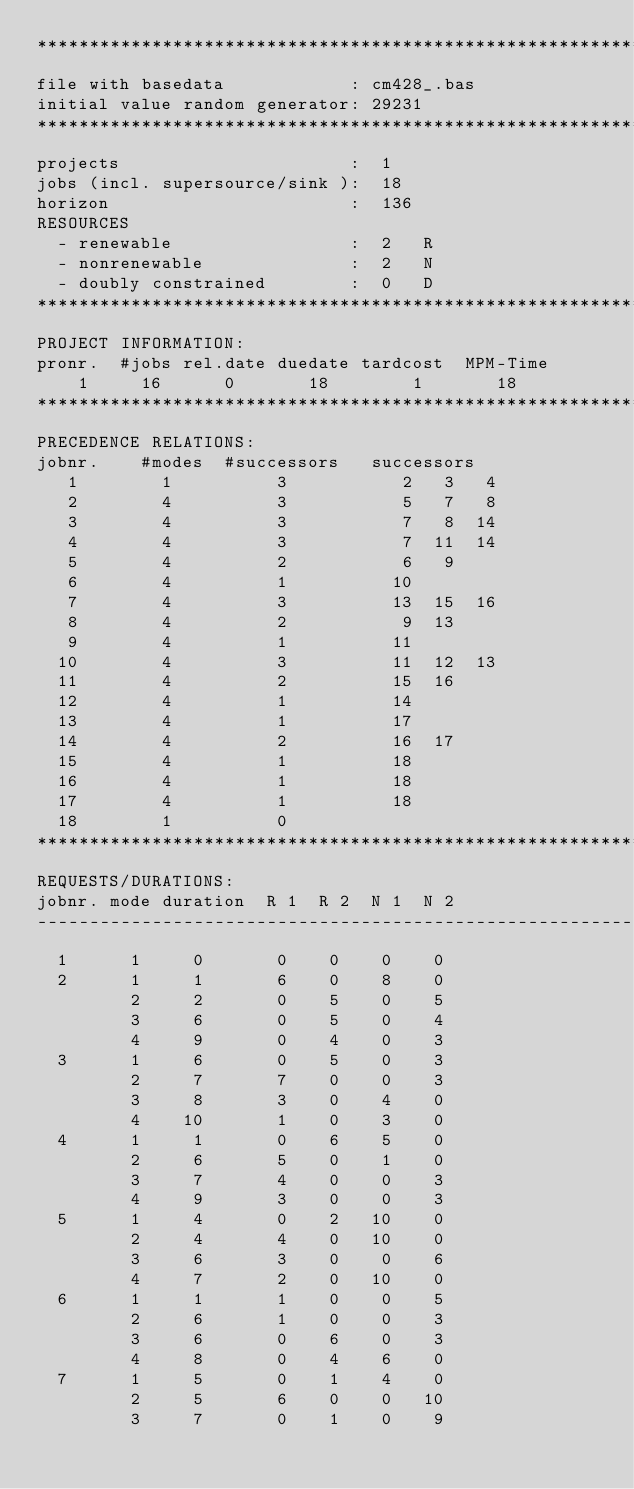Convert code to text. <code><loc_0><loc_0><loc_500><loc_500><_ObjectiveC_>************************************************************************
file with basedata            : cm428_.bas
initial value random generator: 29231
************************************************************************
projects                      :  1
jobs (incl. supersource/sink ):  18
horizon                       :  136
RESOURCES
  - renewable                 :  2   R
  - nonrenewable              :  2   N
  - doubly constrained        :  0   D
************************************************************************
PROJECT INFORMATION:
pronr.  #jobs rel.date duedate tardcost  MPM-Time
    1     16      0       18        1       18
************************************************************************
PRECEDENCE RELATIONS:
jobnr.    #modes  #successors   successors
   1        1          3           2   3   4
   2        4          3           5   7   8
   3        4          3           7   8  14
   4        4          3           7  11  14
   5        4          2           6   9
   6        4          1          10
   7        4          3          13  15  16
   8        4          2           9  13
   9        4          1          11
  10        4          3          11  12  13
  11        4          2          15  16
  12        4          1          14
  13        4          1          17
  14        4          2          16  17
  15        4          1          18
  16        4          1          18
  17        4          1          18
  18        1          0        
************************************************************************
REQUESTS/DURATIONS:
jobnr. mode duration  R 1  R 2  N 1  N 2
------------------------------------------------------------------------
  1      1     0       0    0    0    0
  2      1     1       6    0    8    0
         2     2       0    5    0    5
         3     6       0    5    0    4
         4     9       0    4    0    3
  3      1     6       0    5    0    3
         2     7       7    0    0    3
         3     8       3    0    4    0
         4    10       1    0    3    0
  4      1     1       0    6    5    0
         2     6       5    0    1    0
         3     7       4    0    0    3
         4     9       3    0    0    3
  5      1     4       0    2   10    0
         2     4       4    0   10    0
         3     6       3    0    0    6
         4     7       2    0   10    0
  6      1     1       1    0    0    5
         2     6       1    0    0    3
         3     6       0    6    0    3
         4     8       0    4    6    0
  7      1     5       0    1    4    0
         2     5       6    0    0   10
         3     7       0    1    0    9</code> 